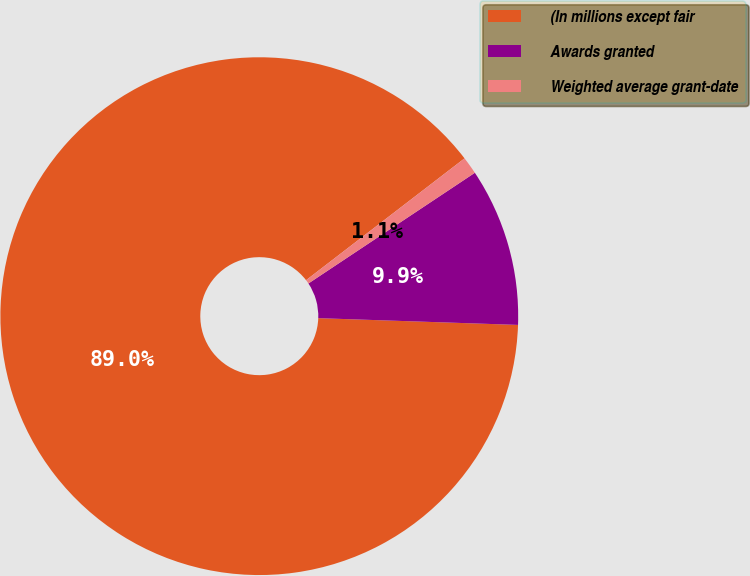Convert chart. <chart><loc_0><loc_0><loc_500><loc_500><pie_chart><fcel>(In millions except fair<fcel>Awards granted<fcel>Weighted average grant-date<nl><fcel>89.03%<fcel>9.88%<fcel>1.09%<nl></chart> 